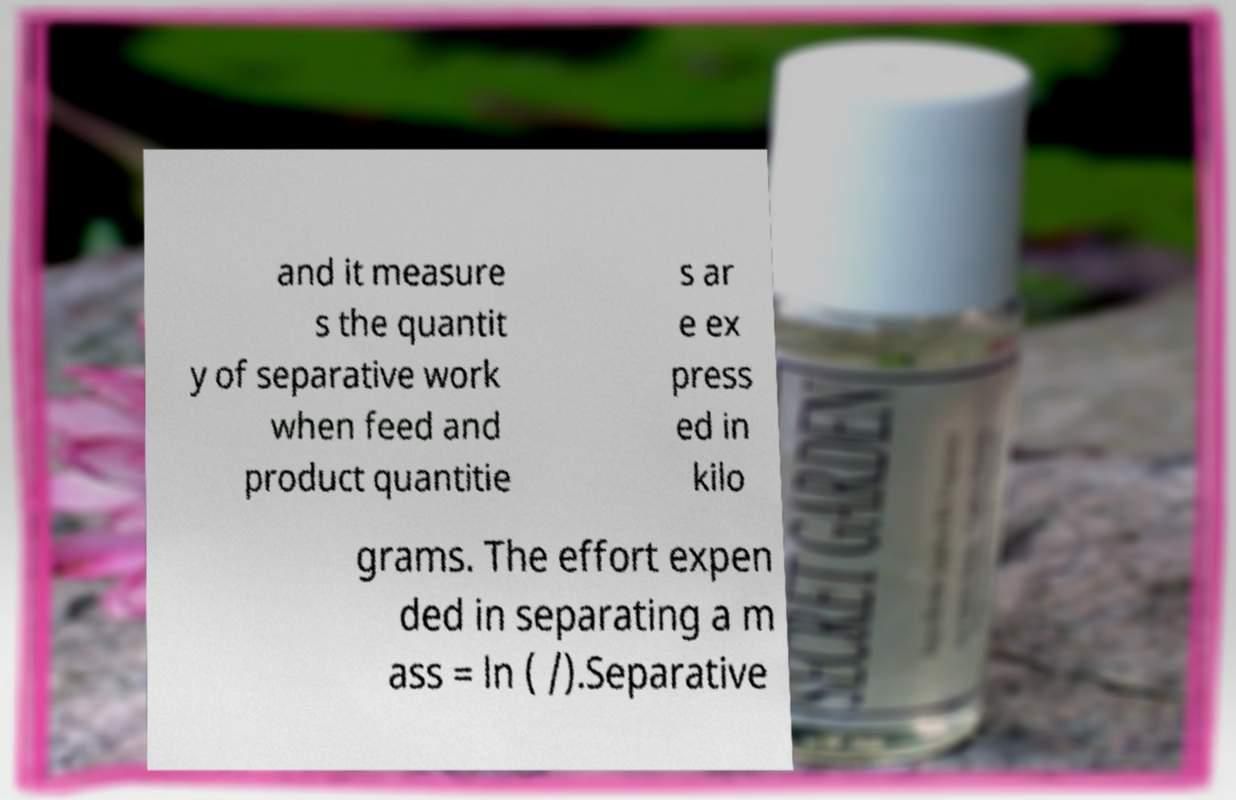Can you read and provide the text displayed in the image?This photo seems to have some interesting text. Can you extract and type it out for me? and it measure s the quantit y of separative work when feed and product quantitie s ar e ex press ed in kilo grams. The effort expen ded in separating a m ass = ln ( /).Separative 